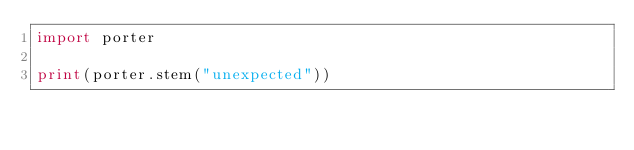<code> <loc_0><loc_0><loc_500><loc_500><_Python_>import porter

print(porter.stem("unexpected"))
</code> 